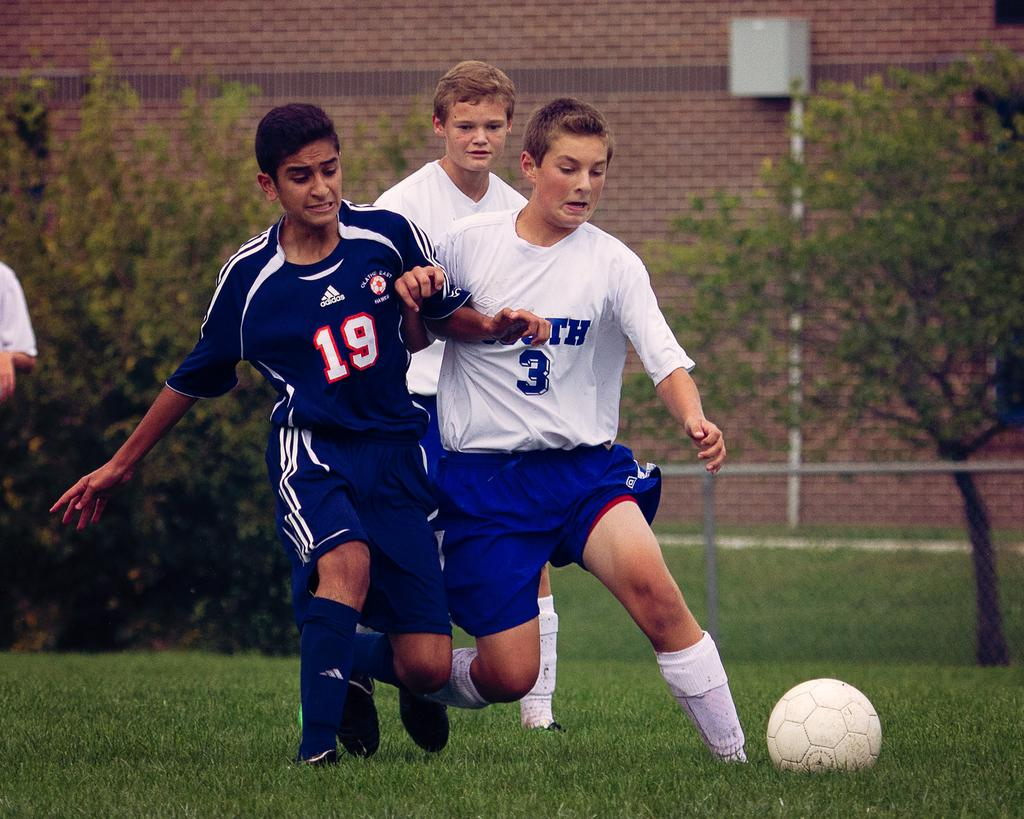<image>
Render a clear and concise summary of the photo. Players 19 and 3 try to each kick the soccer ball. 